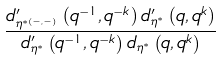Convert formula to latex. <formula><loc_0><loc_0><loc_500><loc_500>\frac { d _ { \eta ^ { \ast ( - , - ) } } ^ { \prime } \left ( q ^ { - 1 } , q ^ { - k } \right ) d _ { \eta ^ { \ast } } ^ { \prime } \left ( q , q ^ { k } \right ) } { d _ { \eta ^ { \ast } } ^ { \prime } \left ( q ^ { - 1 } , q ^ { - k } \right ) d _ { \eta ^ { \ast } } \left ( q , q ^ { k } \right ) }</formula> 